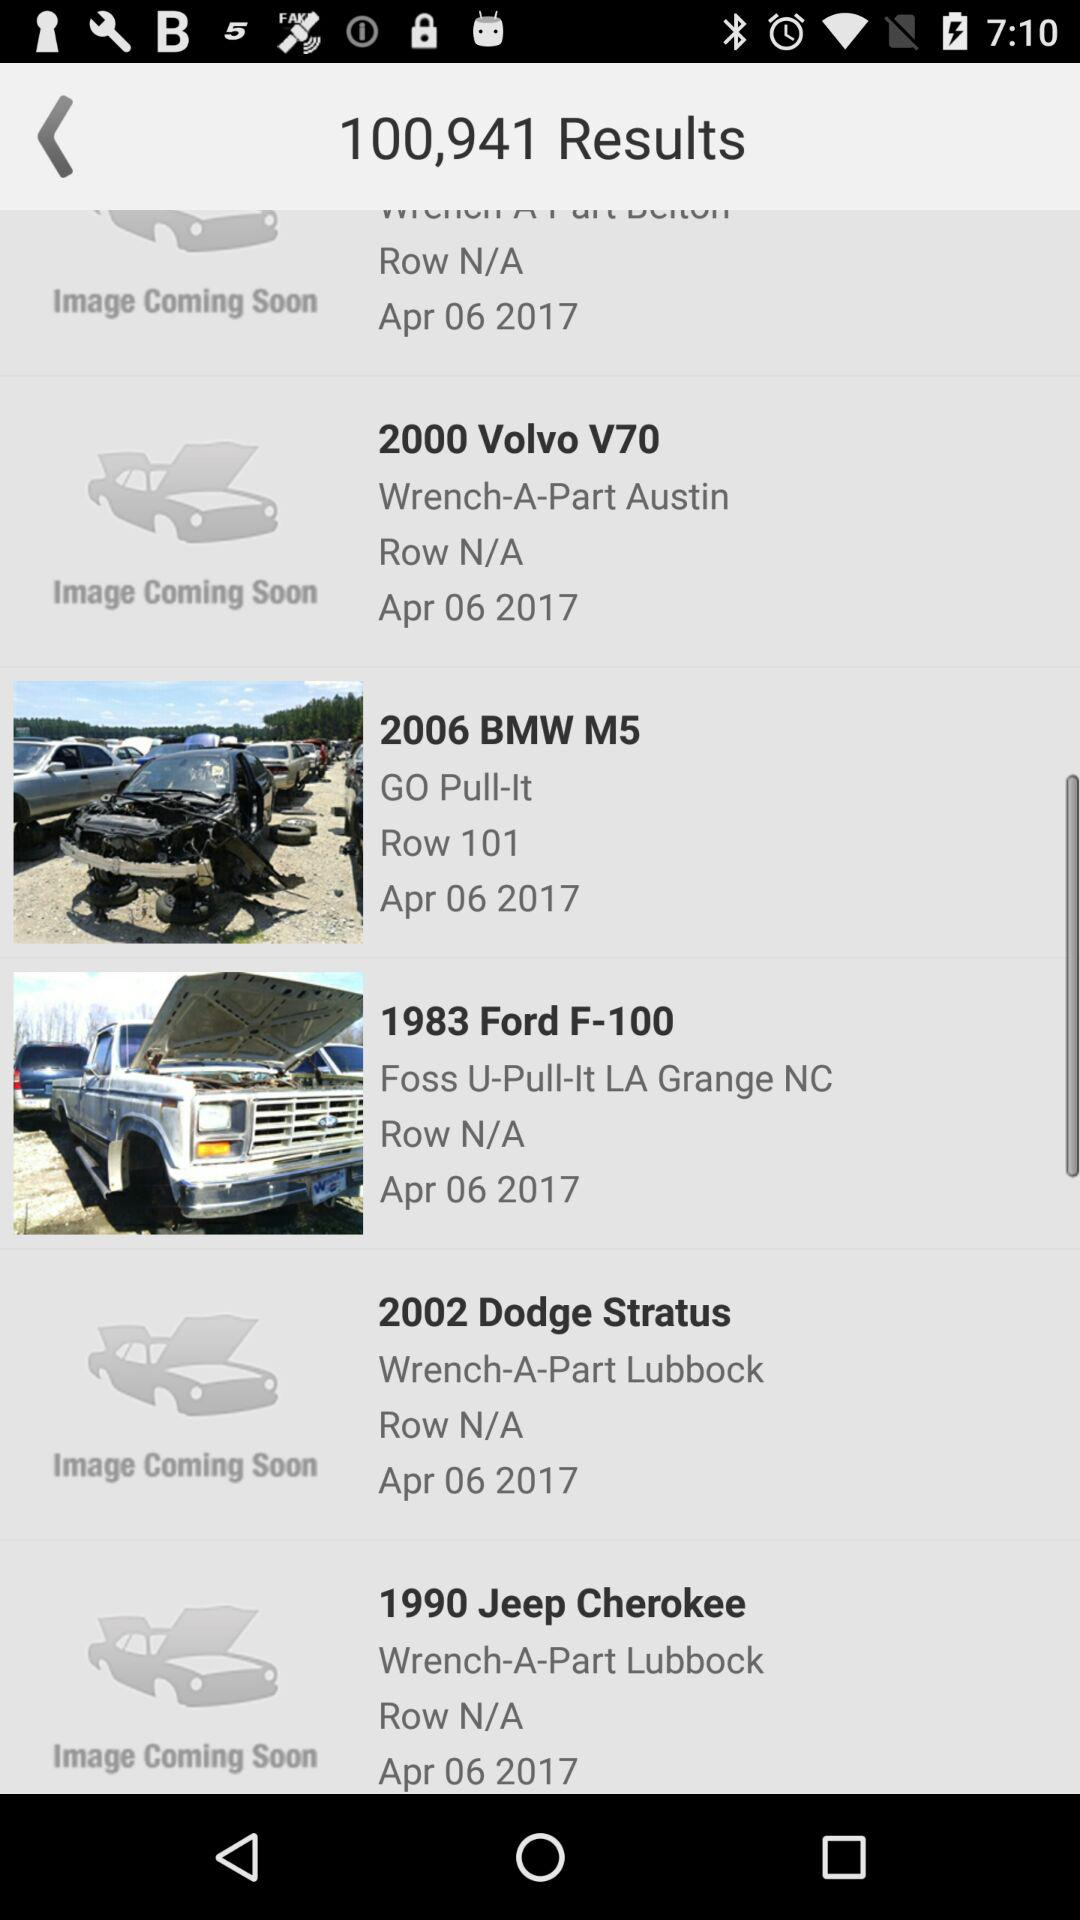What is the name of the application?
When the provided information is insufficient, respond with <no answer>. <no answer> 